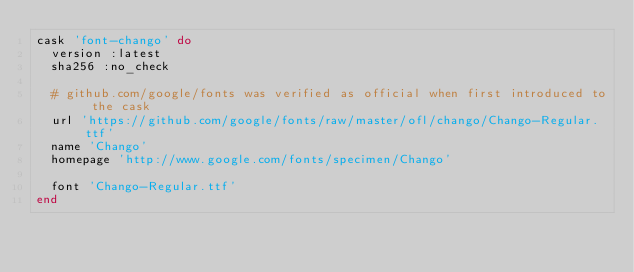<code> <loc_0><loc_0><loc_500><loc_500><_Ruby_>cask 'font-chango' do
  version :latest
  sha256 :no_check

  # github.com/google/fonts was verified as official when first introduced to the cask
  url 'https://github.com/google/fonts/raw/master/ofl/chango/Chango-Regular.ttf'
  name 'Chango'
  homepage 'http://www.google.com/fonts/specimen/Chango'

  font 'Chango-Regular.ttf'
end
</code> 